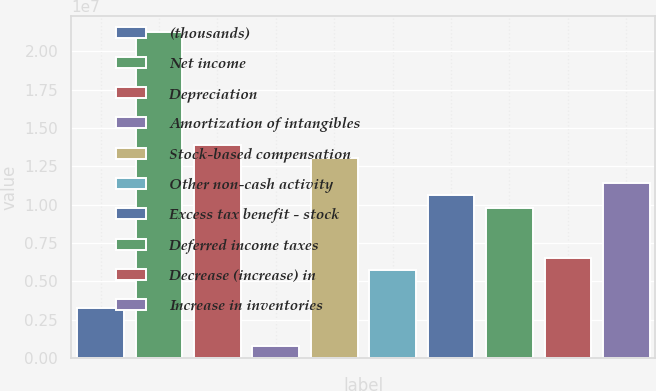Convert chart. <chart><loc_0><loc_0><loc_500><loc_500><bar_chart><fcel>(thousands)<fcel>Net income<fcel>Depreciation<fcel>Amortization of intangibles<fcel>Stock-based compensation<fcel>Other non-cash activity<fcel>Excess tax benefit - stock<fcel>Deferred income taxes<fcel>Decrease (increase) in<fcel>Increase in inventories<nl><fcel>3.26605e+06<fcel>2.1229e+07<fcel>1.38805e+07<fcel>816558<fcel>1.3064e+07<fcel>5.71555e+06<fcel>1.06145e+07<fcel>9.79804e+06<fcel>6.53205e+06<fcel>1.1431e+07<nl></chart> 